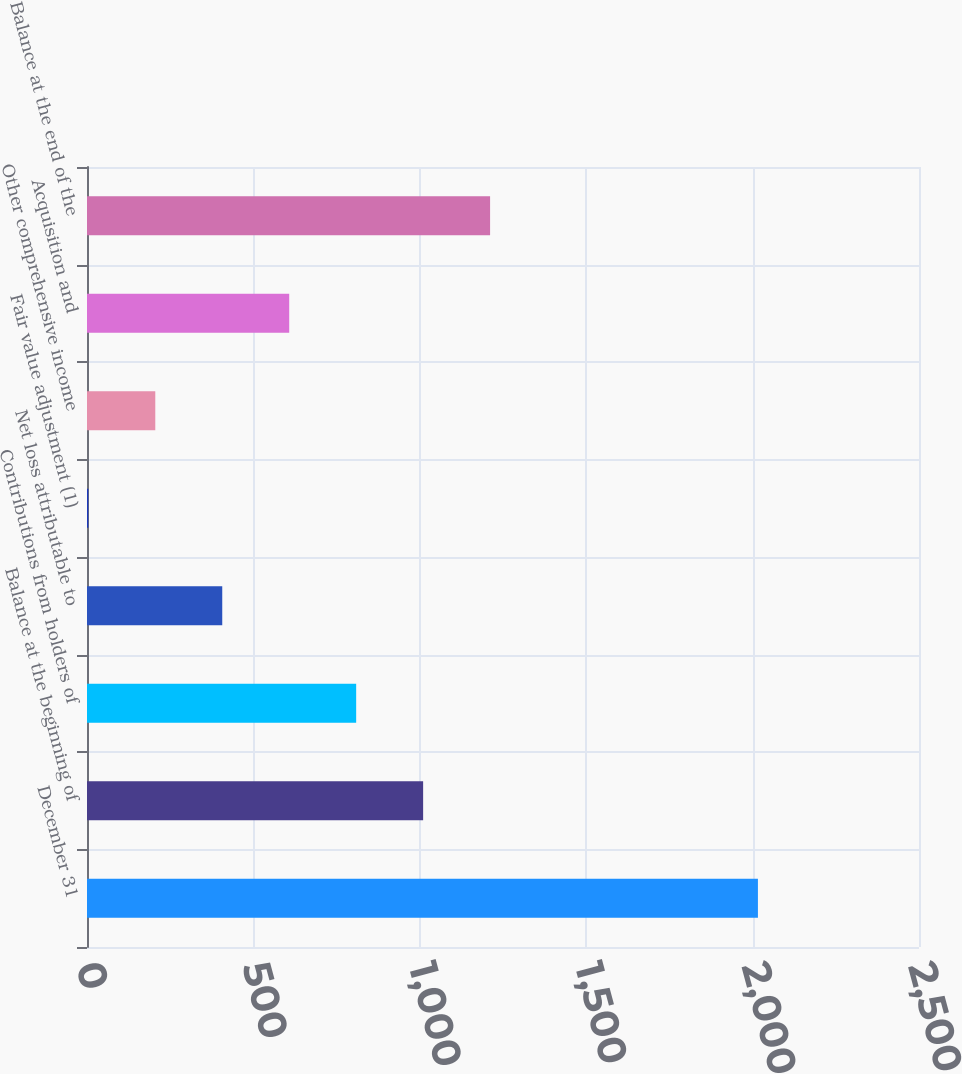Convert chart. <chart><loc_0><loc_0><loc_500><loc_500><bar_chart><fcel>December 31<fcel>Balance at the beginning of<fcel>Contributions from holders of<fcel>Net loss attributable to<fcel>Fair value adjustment (1)<fcel>Other comprehensive income<fcel>Acquisition and<fcel>Balance at the end of the<nl><fcel>2016<fcel>1010<fcel>808.8<fcel>406.4<fcel>4<fcel>205.2<fcel>607.6<fcel>1211.2<nl></chart> 